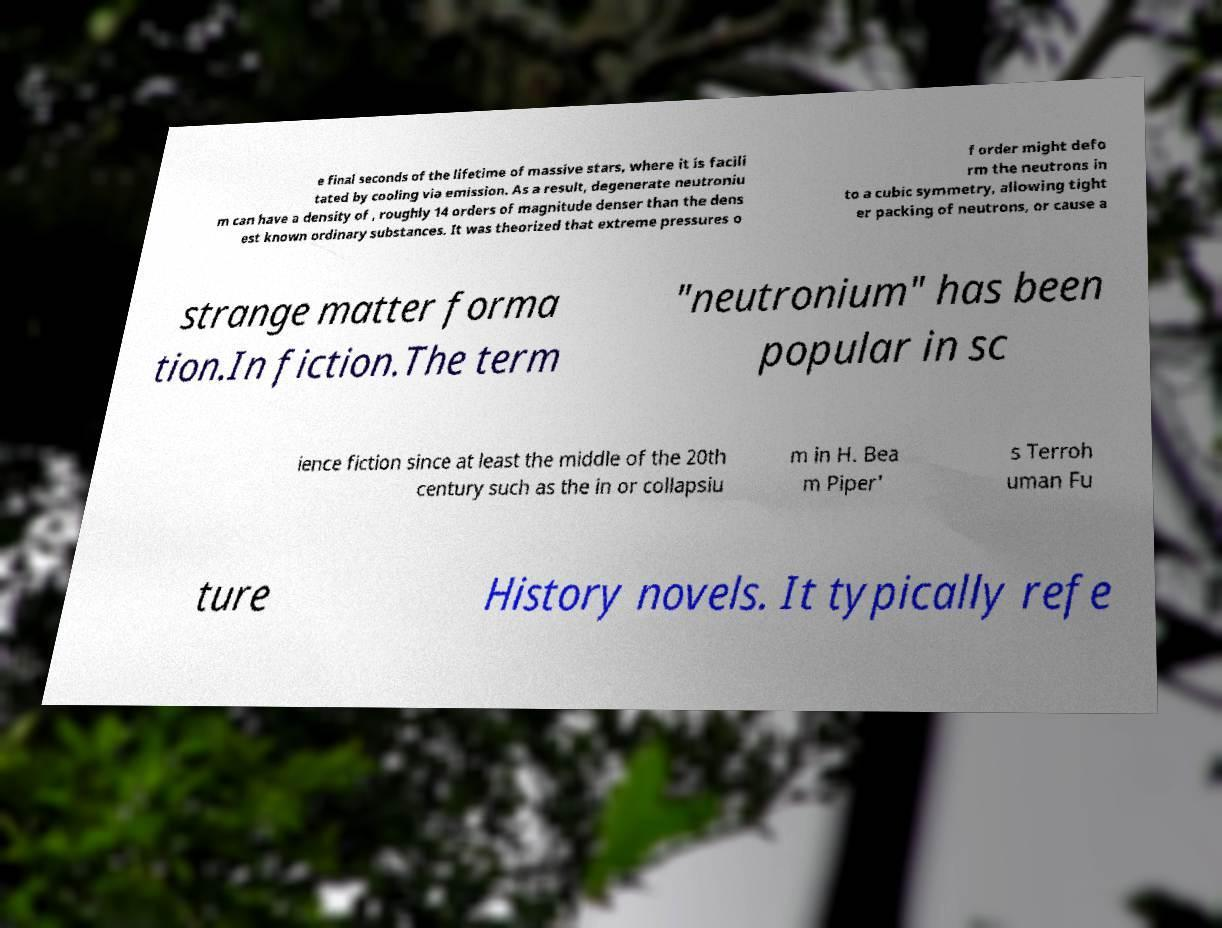Please identify and transcribe the text found in this image. e final seconds of the lifetime of massive stars, where it is facili tated by cooling via emission. As a result, degenerate neutroniu m can have a density of , roughly 14 orders of magnitude denser than the dens est known ordinary substances. It was theorized that extreme pressures o f order might defo rm the neutrons in to a cubic symmetry, allowing tight er packing of neutrons, or cause a strange matter forma tion.In fiction.The term "neutronium" has been popular in sc ience fiction since at least the middle of the 20th century such as the in or collapsiu m in H. Bea m Piper' s Terroh uman Fu ture History novels. It typically refe 